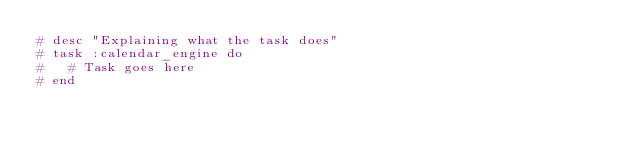<code> <loc_0><loc_0><loc_500><loc_500><_Ruby_># desc "Explaining what the task does"
# task :calendar_engine do
#   # Task goes here
# end
</code> 